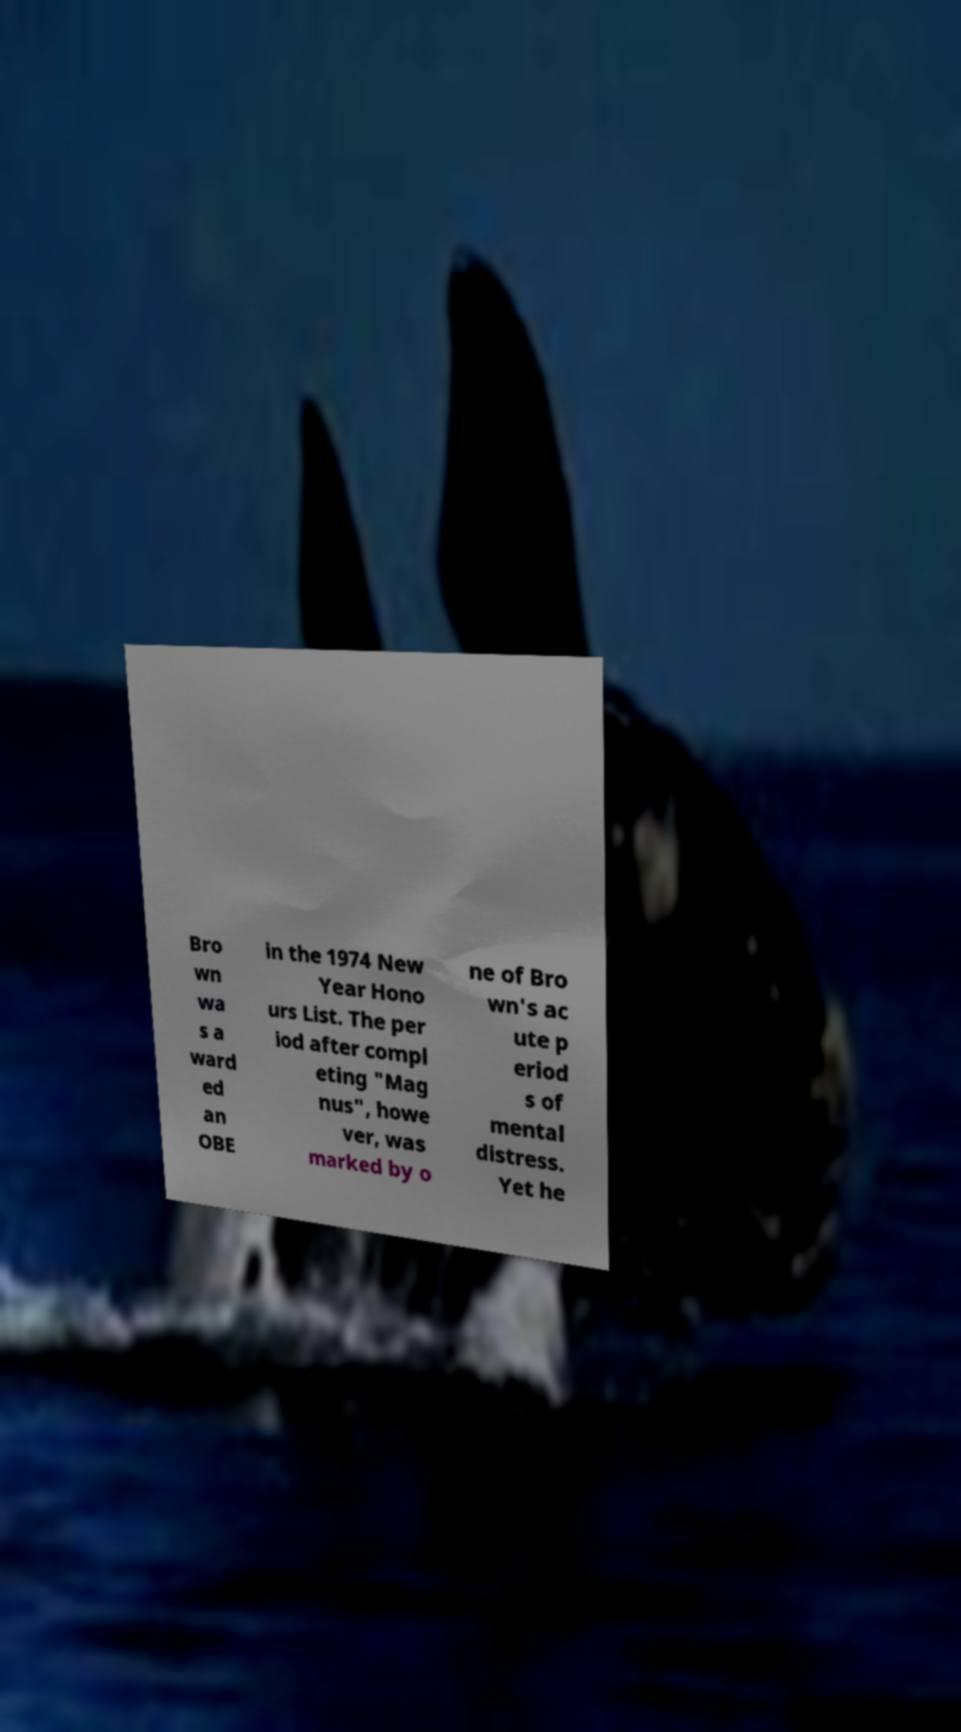What messages or text are displayed in this image? I need them in a readable, typed format. Bro wn wa s a ward ed an OBE in the 1974 New Year Hono urs List. The per iod after compl eting "Mag nus", howe ver, was marked by o ne of Bro wn's ac ute p eriod s of mental distress. Yet he 